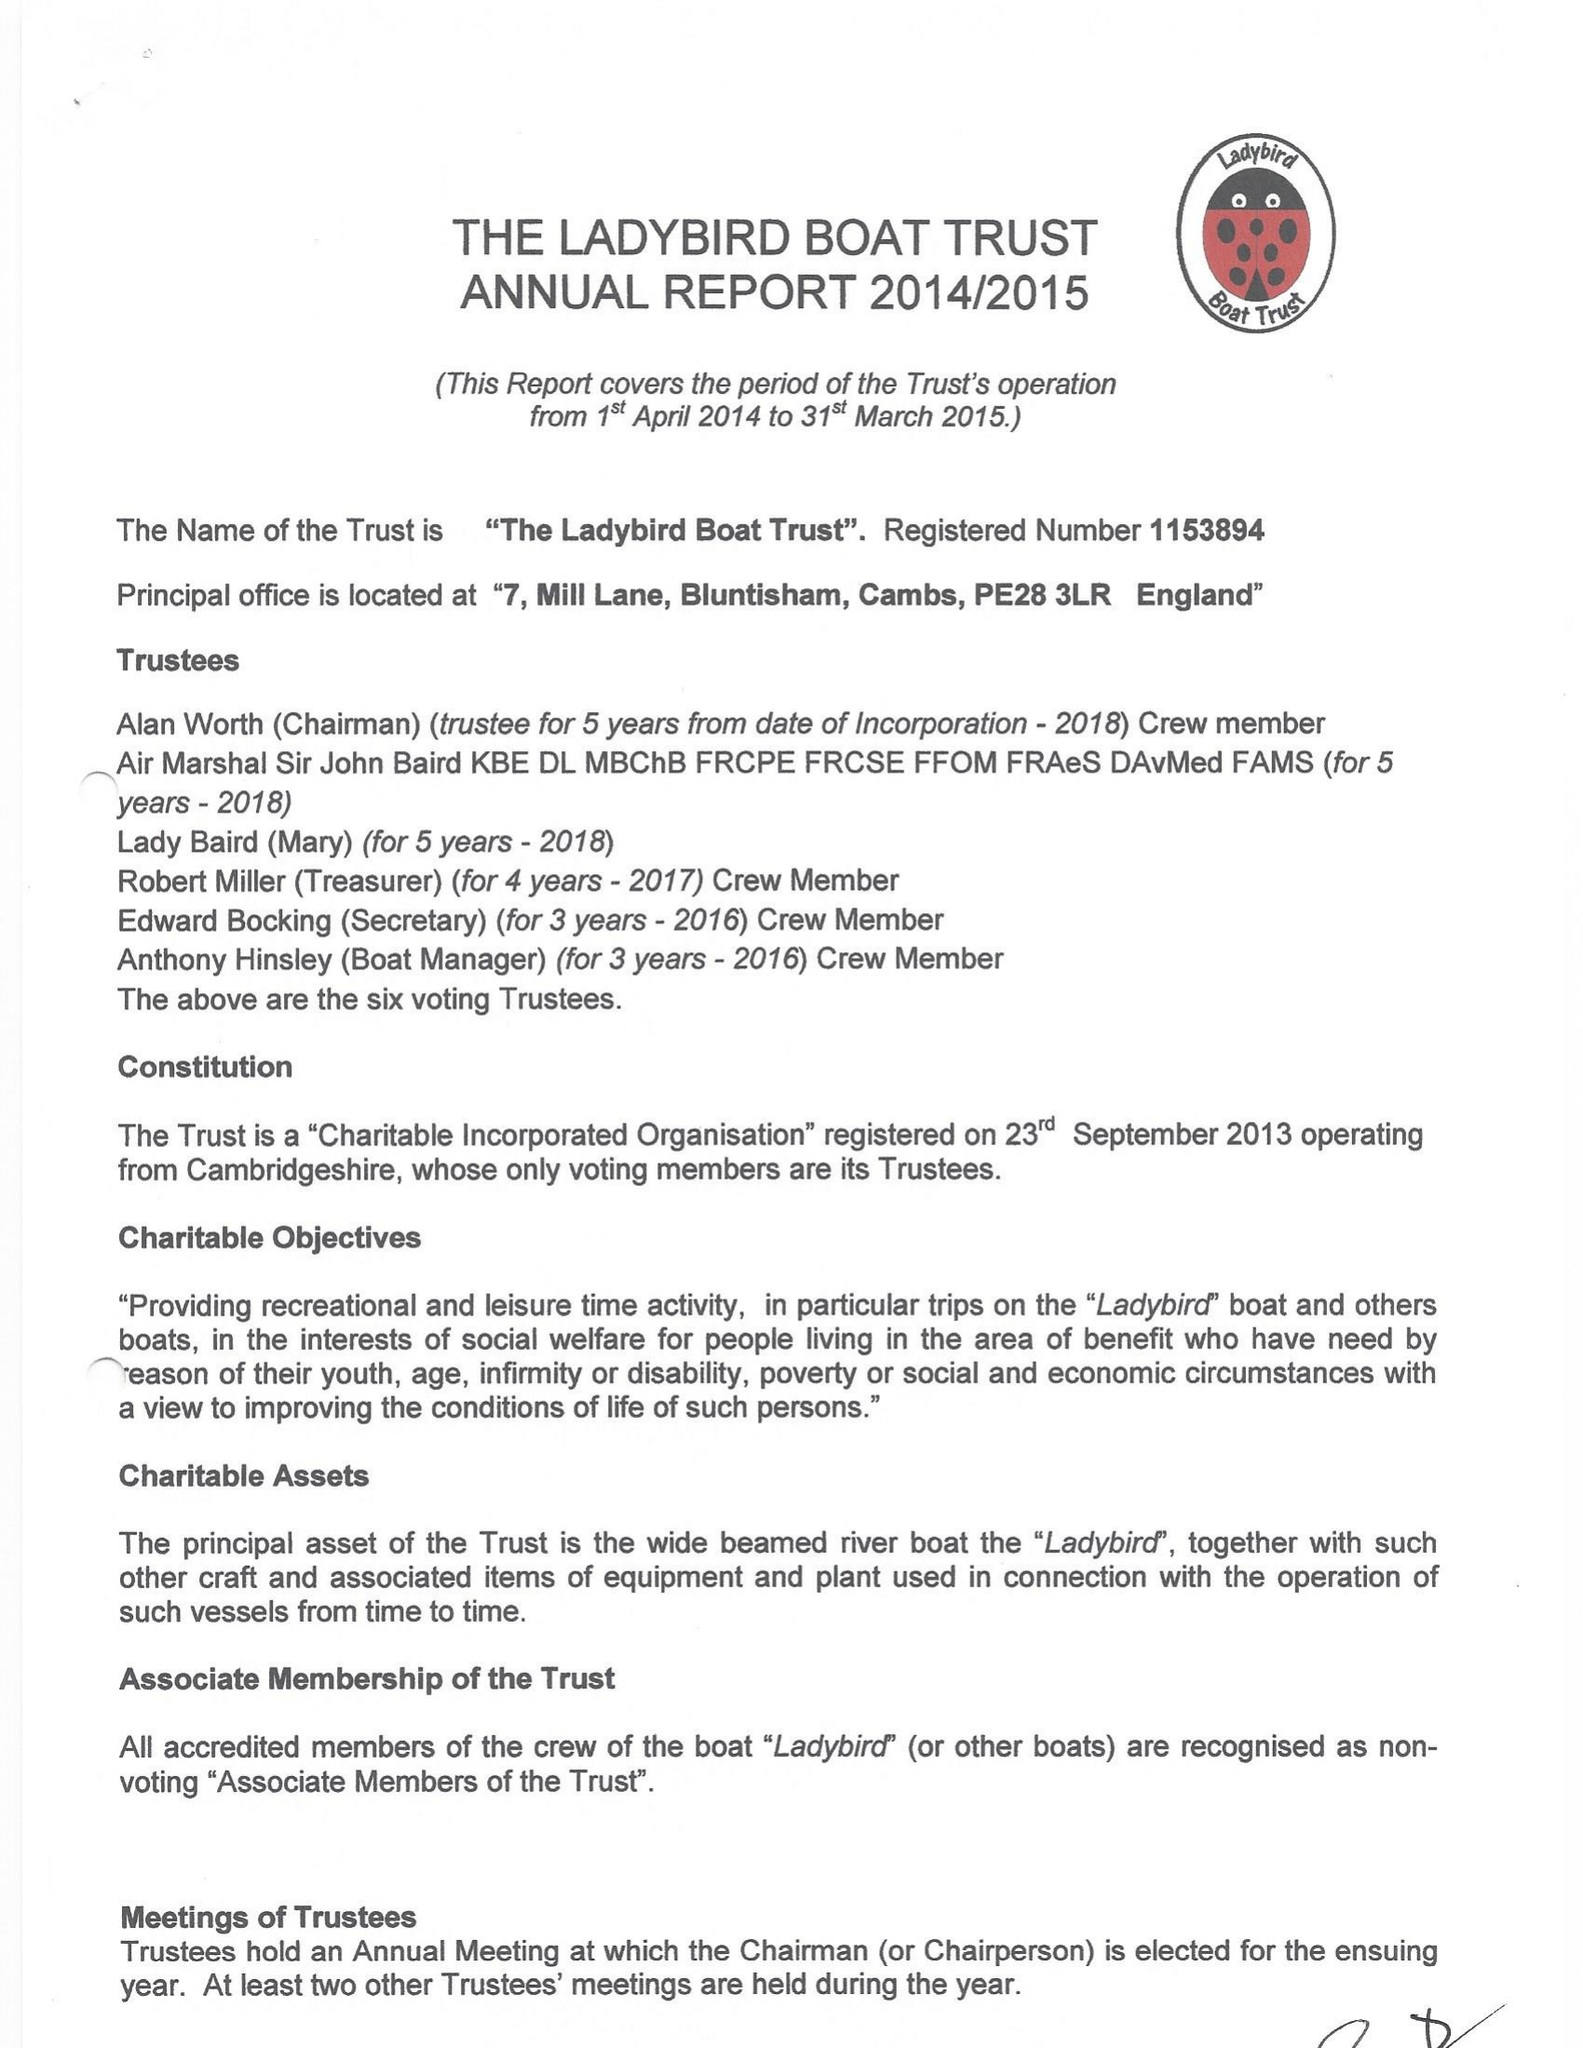What is the value for the charity_number?
Answer the question using a single word or phrase. 1153894 